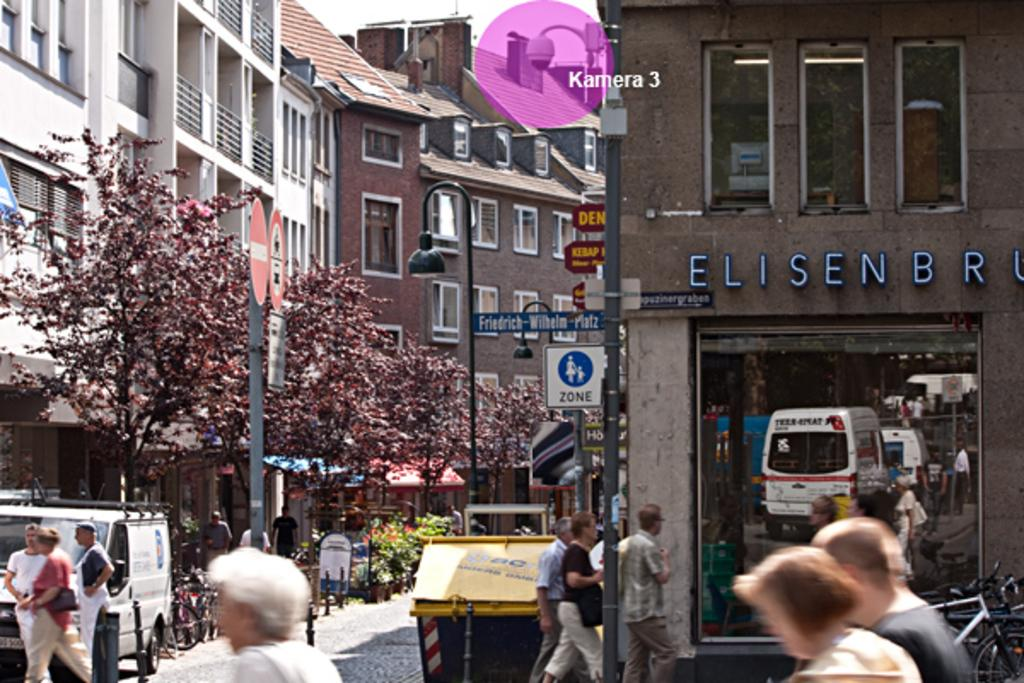What structures can be seen in the image? There are poles, buildings, and sign boards in the image. What objects are present in the image? There are boards, trees, a vehicle, people walking, bollards, and bicycles in the image. What is the setting of the image? There is a road in the image, and the sky is visible at the top. How many passengers are visible in the image? There is no mention of passengers in the image; it features people walking, but their status as passengers cannot be determined. What type of ice can be seen melting on the bicycles in the image? There is no ice present on the bicycles or anywhere else in the image. 